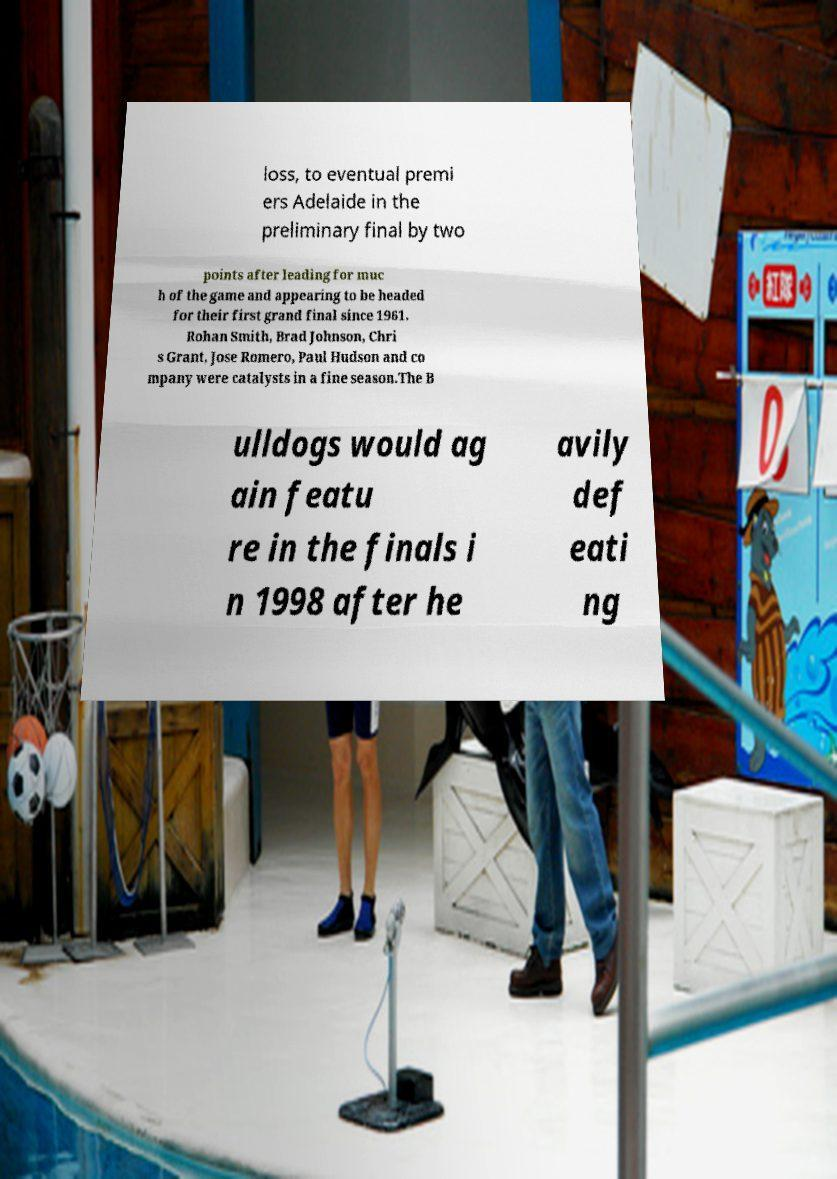What messages or text are displayed in this image? I need them in a readable, typed format. loss, to eventual premi ers Adelaide in the preliminary final by two points after leading for muc h of the game and appearing to be headed for their first grand final since 1961. Rohan Smith, Brad Johnson, Chri s Grant, Jose Romero, Paul Hudson and co mpany were catalysts in a fine season.The B ulldogs would ag ain featu re in the finals i n 1998 after he avily def eati ng 